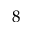Convert formula to latex. <formula><loc_0><loc_0><loc_500><loc_500>8</formula> 